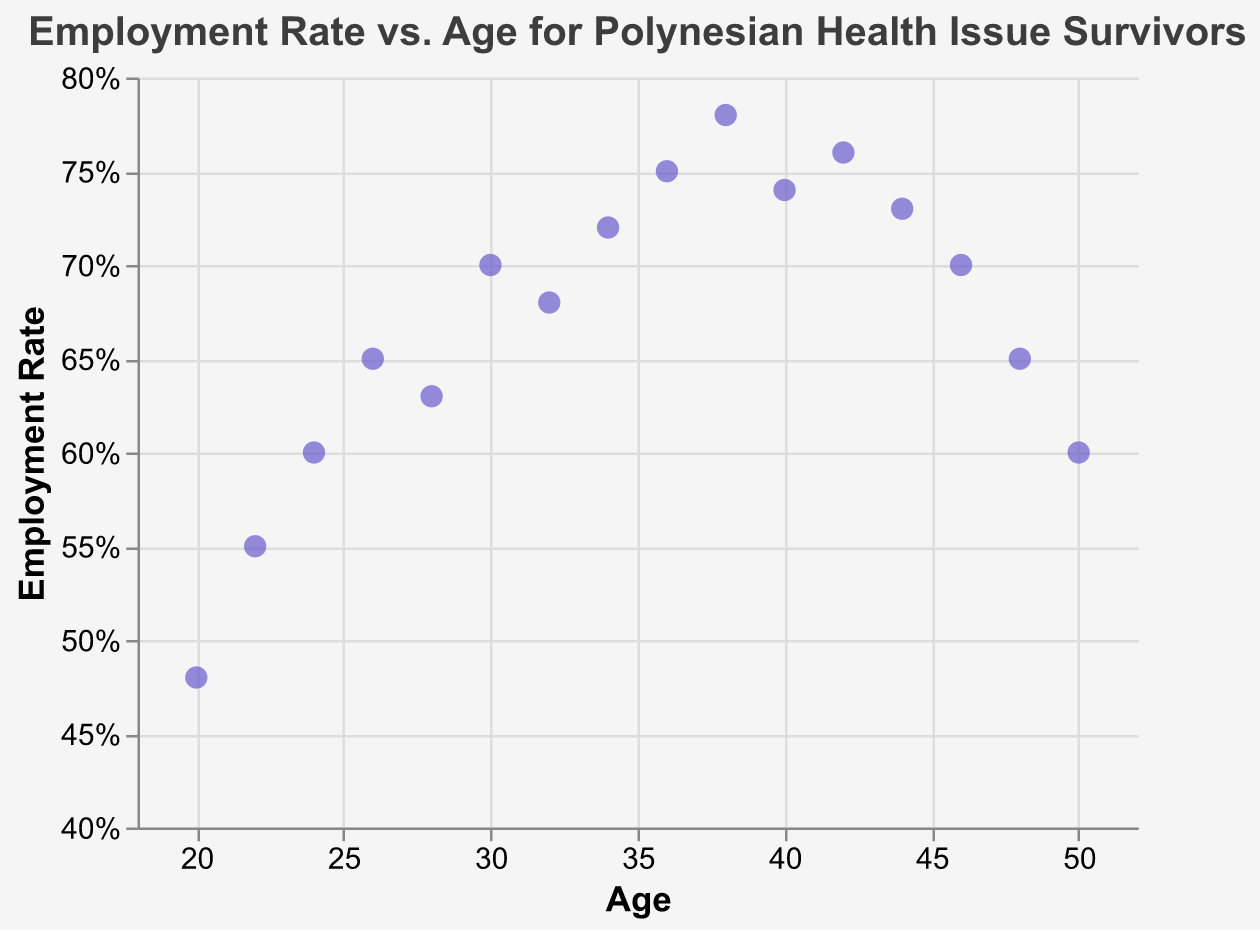How many data points are there in the scatter plot? The scatter plot contains a circle for each data point representing Age and Employment Rate. By counting all the circles on the plot, we find there are 16 data points in total.
Answer: 16 What is the title of the scatter plot? The title is displayed at the top of the scatter plot and reads "Employment Rate vs. Age for Polynesian Health Issue Survivors".
Answer: Employment Rate vs. Age for Polynesian Health Issue Survivors What is the employment rate for a 38-year-old? Locate the data point where Age is 38 on the x-axis, then refer to the corresponding y-axis value for Employment Rate. The data point shows 0.78, which is 78%.
Answer: 78% At what age is the employment rate at its highest? By examining the scatter plot, the highest data point on the y-axis represents the peak employment rate. The age for this data point is 38 years.
Answer: 38 Which age group has a decreasing employment rate after initial growth? To observe trends, identify the portion of the plot where the employment rate initially increases and then decreases. Notice that from age 26 to 38, it increases and after that decreases. The age group from 40 to 50 shows this trend.
Answer: 40-50 What's the average employment rate for individuals aged 30 to 40? Calculate the average by summing the Employment Rates for ages 30, 32, 34, 36, and 38, and then dividing by the number of these ages: (0.70 + 0.68 + 0.72 + 0.75 + 0.78) / 5 = 3.63 / 5 = 0.726.
Answer: 72.6% How does the employment rate for a 24-year-old compare to that for a 48-year-old? Locate the Employment Rates for ages 24 and 48 on the plot. For age 24, it's 0.60; for age 48, it's 0.65. Therefore, the employment rate is higher for a 48-year-old.
Answer: Higher for 48-year-old What is the difference in employment rate between ages 20 and 50? Find the Employment Rates for ages 20 and 50 on the plot. For age 20, it's 48%; for age 50, it's 60%. The difference is 60% - 48% = 12%.
Answer: 12% Is the overall trend in employment rate increasing or decreasing with age? By observing the direction of the plotted data points from the left (age 20) to the right (age 50), we see that the Employment Rate generally increases initially and then decreases. This shows an initial increase followed by a decrease.
Answer: Initial increase followed by decrease What visual encoding is used to represent Age on the scatter plot's axes? The x-axis represents Age, which is encoded quantitatively, meaning each point's horizontal position corresponds to a specific age value.
Answer: Quantitative encoding 